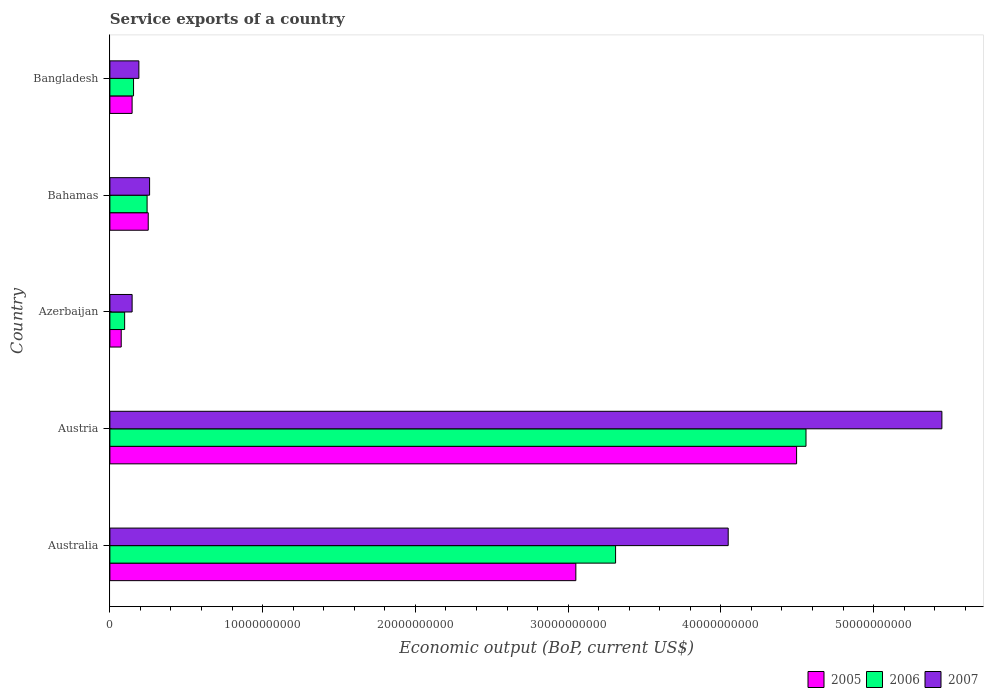How many different coloured bars are there?
Your answer should be compact. 3. Are the number of bars per tick equal to the number of legend labels?
Keep it short and to the point. Yes. Are the number of bars on each tick of the Y-axis equal?
Offer a very short reply. Yes. What is the label of the 5th group of bars from the top?
Keep it short and to the point. Australia. What is the service exports in 2007 in Azerbaijan?
Your response must be concise. 1.46e+09. Across all countries, what is the maximum service exports in 2006?
Provide a succinct answer. 4.56e+1. Across all countries, what is the minimum service exports in 2006?
Offer a very short reply. 9.65e+08. In which country was the service exports in 2007 minimum?
Keep it short and to the point. Azerbaijan. What is the total service exports in 2007 in the graph?
Your answer should be very brief. 1.01e+11. What is the difference between the service exports in 2007 in Azerbaijan and that in Bangladesh?
Make the answer very short. -4.42e+08. What is the difference between the service exports in 2006 in Bangladesh and the service exports in 2007 in Azerbaijan?
Offer a very short reply. 9.36e+07. What is the average service exports in 2007 per country?
Make the answer very short. 2.02e+1. What is the difference between the service exports in 2005 and service exports in 2006 in Bahamas?
Offer a terse response. 7.48e+07. In how many countries, is the service exports in 2005 greater than 54000000000 US$?
Keep it short and to the point. 0. What is the ratio of the service exports in 2007 in Azerbaijan to that in Bahamas?
Make the answer very short. 0.56. Is the difference between the service exports in 2005 in Austria and Azerbaijan greater than the difference between the service exports in 2006 in Austria and Azerbaijan?
Provide a short and direct response. No. What is the difference between the highest and the second highest service exports in 2007?
Provide a short and direct response. 1.40e+1. What is the difference between the highest and the lowest service exports in 2007?
Give a very brief answer. 5.30e+1. In how many countries, is the service exports in 2006 greater than the average service exports in 2006 taken over all countries?
Your answer should be very brief. 2. What does the 2nd bar from the top in Bangladesh represents?
Provide a short and direct response. 2006. How many bars are there?
Your answer should be very brief. 15. How many countries are there in the graph?
Provide a succinct answer. 5. Does the graph contain any zero values?
Provide a short and direct response. No. Where does the legend appear in the graph?
Provide a short and direct response. Bottom right. How many legend labels are there?
Your answer should be very brief. 3. What is the title of the graph?
Give a very brief answer. Service exports of a country. Does "2014" appear as one of the legend labels in the graph?
Make the answer very short. No. What is the label or title of the X-axis?
Your response must be concise. Economic output (BoP, current US$). What is the label or title of the Y-axis?
Your answer should be very brief. Country. What is the Economic output (BoP, current US$) in 2005 in Australia?
Offer a very short reply. 3.05e+1. What is the Economic output (BoP, current US$) in 2006 in Australia?
Offer a very short reply. 3.31e+1. What is the Economic output (BoP, current US$) in 2007 in Australia?
Your response must be concise. 4.05e+1. What is the Economic output (BoP, current US$) of 2005 in Austria?
Provide a succinct answer. 4.50e+1. What is the Economic output (BoP, current US$) in 2006 in Austria?
Your answer should be compact. 4.56e+1. What is the Economic output (BoP, current US$) in 2007 in Austria?
Your answer should be compact. 5.45e+1. What is the Economic output (BoP, current US$) in 2005 in Azerbaijan?
Your response must be concise. 7.41e+08. What is the Economic output (BoP, current US$) in 2006 in Azerbaijan?
Provide a short and direct response. 9.65e+08. What is the Economic output (BoP, current US$) in 2007 in Azerbaijan?
Your answer should be very brief. 1.46e+09. What is the Economic output (BoP, current US$) in 2005 in Bahamas?
Provide a short and direct response. 2.51e+09. What is the Economic output (BoP, current US$) in 2006 in Bahamas?
Keep it short and to the point. 2.44e+09. What is the Economic output (BoP, current US$) in 2007 in Bahamas?
Keep it short and to the point. 2.60e+09. What is the Economic output (BoP, current US$) in 2005 in Bangladesh?
Keep it short and to the point. 1.45e+09. What is the Economic output (BoP, current US$) in 2006 in Bangladesh?
Your response must be concise. 1.55e+09. What is the Economic output (BoP, current US$) of 2007 in Bangladesh?
Make the answer very short. 1.90e+09. Across all countries, what is the maximum Economic output (BoP, current US$) in 2005?
Ensure brevity in your answer.  4.50e+1. Across all countries, what is the maximum Economic output (BoP, current US$) in 2006?
Ensure brevity in your answer.  4.56e+1. Across all countries, what is the maximum Economic output (BoP, current US$) of 2007?
Provide a short and direct response. 5.45e+1. Across all countries, what is the minimum Economic output (BoP, current US$) of 2005?
Keep it short and to the point. 7.41e+08. Across all countries, what is the minimum Economic output (BoP, current US$) of 2006?
Make the answer very short. 9.65e+08. Across all countries, what is the minimum Economic output (BoP, current US$) of 2007?
Offer a terse response. 1.46e+09. What is the total Economic output (BoP, current US$) of 2005 in the graph?
Make the answer very short. 8.02e+1. What is the total Economic output (BoP, current US$) of 2006 in the graph?
Your response must be concise. 8.36e+1. What is the total Economic output (BoP, current US$) in 2007 in the graph?
Keep it short and to the point. 1.01e+11. What is the difference between the Economic output (BoP, current US$) of 2005 in Australia and that in Austria?
Give a very brief answer. -1.45e+1. What is the difference between the Economic output (BoP, current US$) in 2006 in Australia and that in Austria?
Your answer should be very brief. -1.25e+1. What is the difference between the Economic output (BoP, current US$) in 2007 in Australia and that in Austria?
Your answer should be compact. -1.40e+1. What is the difference between the Economic output (BoP, current US$) in 2005 in Australia and that in Azerbaijan?
Offer a terse response. 2.98e+1. What is the difference between the Economic output (BoP, current US$) of 2006 in Australia and that in Azerbaijan?
Your response must be concise. 3.21e+1. What is the difference between the Economic output (BoP, current US$) in 2007 in Australia and that in Azerbaijan?
Offer a terse response. 3.90e+1. What is the difference between the Economic output (BoP, current US$) in 2005 in Australia and that in Bahamas?
Make the answer very short. 2.80e+1. What is the difference between the Economic output (BoP, current US$) in 2006 in Australia and that in Bahamas?
Your answer should be very brief. 3.07e+1. What is the difference between the Economic output (BoP, current US$) of 2007 in Australia and that in Bahamas?
Provide a succinct answer. 3.79e+1. What is the difference between the Economic output (BoP, current US$) of 2005 in Australia and that in Bangladesh?
Provide a short and direct response. 2.91e+1. What is the difference between the Economic output (BoP, current US$) in 2006 in Australia and that in Bangladesh?
Offer a very short reply. 3.16e+1. What is the difference between the Economic output (BoP, current US$) of 2007 in Australia and that in Bangladesh?
Make the answer very short. 3.86e+1. What is the difference between the Economic output (BoP, current US$) in 2005 in Austria and that in Azerbaijan?
Offer a terse response. 4.42e+1. What is the difference between the Economic output (BoP, current US$) in 2006 in Austria and that in Azerbaijan?
Provide a succinct answer. 4.46e+1. What is the difference between the Economic output (BoP, current US$) in 2007 in Austria and that in Azerbaijan?
Provide a succinct answer. 5.30e+1. What is the difference between the Economic output (BoP, current US$) in 2005 in Austria and that in Bahamas?
Make the answer very short. 4.24e+1. What is the difference between the Economic output (BoP, current US$) of 2006 in Austria and that in Bahamas?
Offer a terse response. 4.31e+1. What is the difference between the Economic output (BoP, current US$) in 2007 in Austria and that in Bahamas?
Your answer should be very brief. 5.19e+1. What is the difference between the Economic output (BoP, current US$) of 2005 in Austria and that in Bangladesh?
Make the answer very short. 4.35e+1. What is the difference between the Economic output (BoP, current US$) in 2006 in Austria and that in Bangladesh?
Offer a very short reply. 4.40e+1. What is the difference between the Economic output (BoP, current US$) in 2007 in Austria and that in Bangladesh?
Keep it short and to the point. 5.26e+1. What is the difference between the Economic output (BoP, current US$) in 2005 in Azerbaijan and that in Bahamas?
Keep it short and to the point. -1.77e+09. What is the difference between the Economic output (BoP, current US$) of 2006 in Azerbaijan and that in Bahamas?
Ensure brevity in your answer.  -1.47e+09. What is the difference between the Economic output (BoP, current US$) of 2007 in Azerbaijan and that in Bahamas?
Your answer should be compact. -1.14e+09. What is the difference between the Economic output (BoP, current US$) of 2005 in Azerbaijan and that in Bangladesh?
Provide a short and direct response. -7.13e+08. What is the difference between the Economic output (BoP, current US$) in 2006 in Azerbaijan and that in Bangladesh?
Your answer should be compact. -5.84e+08. What is the difference between the Economic output (BoP, current US$) of 2007 in Azerbaijan and that in Bangladesh?
Your response must be concise. -4.42e+08. What is the difference between the Economic output (BoP, current US$) of 2005 in Bahamas and that in Bangladesh?
Provide a short and direct response. 1.06e+09. What is the difference between the Economic output (BoP, current US$) of 2006 in Bahamas and that in Bangladesh?
Offer a very short reply. 8.87e+08. What is the difference between the Economic output (BoP, current US$) of 2007 in Bahamas and that in Bangladesh?
Your answer should be very brief. 7.02e+08. What is the difference between the Economic output (BoP, current US$) in 2005 in Australia and the Economic output (BoP, current US$) in 2006 in Austria?
Offer a very short reply. -1.51e+1. What is the difference between the Economic output (BoP, current US$) of 2005 in Australia and the Economic output (BoP, current US$) of 2007 in Austria?
Your answer should be compact. -2.40e+1. What is the difference between the Economic output (BoP, current US$) in 2006 in Australia and the Economic output (BoP, current US$) in 2007 in Austria?
Keep it short and to the point. -2.14e+1. What is the difference between the Economic output (BoP, current US$) of 2005 in Australia and the Economic output (BoP, current US$) of 2006 in Azerbaijan?
Offer a terse response. 2.95e+1. What is the difference between the Economic output (BoP, current US$) in 2005 in Australia and the Economic output (BoP, current US$) in 2007 in Azerbaijan?
Provide a short and direct response. 2.91e+1. What is the difference between the Economic output (BoP, current US$) of 2006 in Australia and the Economic output (BoP, current US$) of 2007 in Azerbaijan?
Offer a terse response. 3.17e+1. What is the difference between the Economic output (BoP, current US$) of 2005 in Australia and the Economic output (BoP, current US$) of 2006 in Bahamas?
Keep it short and to the point. 2.81e+1. What is the difference between the Economic output (BoP, current US$) in 2005 in Australia and the Economic output (BoP, current US$) in 2007 in Bahamas?
Your answer should be very brief. 2.79e+1. What is the difference between the Economic output (BoP, current US$) in 2006 in Australia and the Economic output (BoP, current US$) in 2007 in Bahamas?
Provide a succinct answer. 3.05e+1. What is the difference between the Economic output (BoP, current US$) of 2005 in Australia and the Economic output (BoP, current US$) of 2006 in Bangladesh?
Give a very brief answer. 2.90e+1. What is the difference between the Economic output (BoP, current US$) of 2005 in Australia and the Economic output (BoP, current US$) of 2007 in Bangladesh?
Make the answer very short. 2.86e+1. What is the difference between the Economic output (BoP, current US$) in 2006 in Australia and the Economic output (BoP, current US$) in 2007 in Bangladesh?
Your response must be concise. 3.12e+1. What is the difference between the Economic output (BoP, current US$) in 2005 in Austria and the Economic output (BoP, current US$) in 2006 in Azerbaijan?
Offer a terse response. 4.40e+1. What is the difference between the Economic output (BoP, current US$) of 2005 in Austria and the Economic output (BoP, current US$) of 2007 in Azerbaijan?
Give a very brief answer. 4.35e+1. What is the difference between the Economic output (BoP, current US$) in 2006 in Austria and the Economic output (BoP, current US$) in 2007 in Azerbaijan?
Your answer should be compact. 4.41e+1. What is the difference between the Economic output (BoP, current US$) of 2005 in Austria and the Economic output (BoP, current US$) of 2006 in Bahamas?
Give a very brief answer. 4.25e+1. What is the difference between the Economic output (BoP, current US$) of 2005 in Austria and the Economic output (BoP, current US$) of 2007 in Bahamas?
Your answer should be very brief. 4.24e+1. What is the difference between the Economic output (BoP, current US$) of 2006 in Austria and the Economic output (BoP, current US$) of 2007 in Bahamas?
Make the answer very short. 4.30e+1. What is the difference between the Economic output (BoP, current US$) of 2005 in Austria and the Economic output (BoP, current US$) of 2006 in Bangladesh?
Offer a very short reply. 4.34e+1. What is the difference between the Economic output (BoP, current US$) in 2005 in Austria and the Economic output (BoP, current US$) in 2007 in Bangladesh?
Your answer should be very brief. 4.31e+1. What is the difference between the Economic output (BoP, current US$) of 2006 in Austria and the Economic output (BoP, current US$) of 2007 in Bangladesh?
Ensure brevity in your answer.  4.37e+1. What is the difference between the Economic output (BoP, current US$) of 2005 in Azerbaijan and the Economic output (BoP, current US$) of 2006 in Bahamas?
Your answer should be very brief. -1.69e+09. What is the difference between the Economic output (BoP, current US$) of 2005 in Azerbaijan and the Economic output (BoP, current US$) of 2007 in Bahamas?
Give a very brief answer. -1.86e+09. What is the difference between the Economic output (BoP, current US$) of 2006 in Azerbaijan and the Economic output (BoP, current US$) of 2007 in Bahamas?
Your answer should be compact. -1.63e+09. What is the difference between the Economic output (BoP, current US$) of 2005 in Azerbaijan and the Economic output (BoP, current US$) of 2006 in Bangladesh?
Offer a very short reply. -8.08e+08. What is the difference between the Economic output (BoP, current US$) of 2005 in Azerbaijan and the Economic output (BoP, current US$) of 2007 in Bangladesh?
Provide a succinct answer. -1.16e+09. What is the difference between the Economic output (BoP, current US$) in 2006 in Azerbaijan and the Economic output (BoP, current US$) in 2007 in Bangladesh?
Give a very brief answer. -9.32e+08. What is the difference between the Economic output (BoP, current US$) of 2005 in Bahamas and the Economic output (BoP, current US$) of 2006 in Bangladesh?
Your response must be concise. 9.62e+08. What is the difference between the Economic output (BoP, current US$) in 2005 in Bahamas and the Economic output (BoP, current US$) in 2007 in Bangladesh?
Ensure brevity in your answer.  6.14e+08. What is the difference between the Economic output (BoP, current US$) in 2006 in Bahamas and the Economic output (BoP, current US$) in 2007 in Bangladesh?
Keep it short and to the point. 5.39e+08. What is the average Economic output (BoP, current US$) in 2005 per country?
Provide a succinct answer. 1.60e+1. What is the average Economic output (BoP, current US$) in 2006 per country?
Your response must be concise. 1.67e+1. What is the average Economic output (BoP, current US$) of 2007 per country?
Give a very brief answer. 2.02e+1. What is the difference between the Economic output (BoP, current US$) of 2005 and Economic output (BoP, current US$) of 2006 in Australia?
Your response must be concise. -2.60e+09. What is the difference between the Economic output (BoP, current US$) of 2005 and Economic output (BoP, current US$) of 2007 in Australia?
Ensure brevity in your answer.  -9.97e+09. What is the difference between the Economic output (BoP, current US$) in 2006 and Economic output (BoP, current US$) in 2007 in Australia?
Provide a short and direct response. -7.37e+09. What is the difference between the Economic output (BoP, current US$) in 2005 and Economic output (BoP, current US$) in 2006 in Austria?
Provide a short and direct response. -6.15e+08. What is the difference between the Economic output (BoP, current US$) of 2005 and Economic output (BoP, current US$) of 2007 in Austria?
Offer a very short reply. -9.51e+09. What is the difference between the Economic output (BoP, current US$) in 2006 and Economic output (BoP, current US$) in 2007 in Austria?
Your response must be concise. -8.90e+09. What is the difference between the Economic output (BoP, current US$) in 2005 and Economic output (BoP, current US$) in 2006 in Azerbaijan?
Your answer should be compact. -2.24e+08. What is the difference between the Economic output (BoP, current US$) of 2005 and Economic output (BoP, current US$) of 2007 in Azerbaijan?
Offer a very short reply. -7.14e+08. What is the difference between the Economic output (BoP, current US$) in 2006 and Economic output (BoP, current US$) in 2007 in Azerbaijan?
Ensure brevity in your answer.  -4.90e+08. What is the difference between the Economic output (BoP, current US$) in 2005 and Economic output (BoP, current US$) in 2006 in Bahamas?
Keep it short and to the point. 7.48e+07. What is the difference between the Economic output (BoP, current US$) of 2005 and Economic output (BoP, current US$) of 2007 in Bahamas?
Give a very brief answer. -8.84e+07. What is the difference between the Economic output (BoP, current US$) of 2006 and Economic output (BoP, current US$) of 2007 in Bahamas?
Your answer should be compact. -1.63e+08. What is the difference between the Economic output (BoP, current US$) in 2005 and Economic output (BoP, current US$) in 2006 in Bangladesh?
Your answer should be very brief. -9.44e+07. What is the difference between the Economic output (BoP, current US$) in 2005 and Economic output (BoP, current US$) in 2007 in Bangladesh?
Provide a succinct answer. -4.43e+08. What is the difference between the Economic output (BoP, current US$) in 2006 and Economic output (BoP, current US$) in 2007 in Bangladesh?
Offer a very short reply. -3.48e+08. What is the ratio of the Economic output (BoP, current US$) in 2005 in Australia to that in Austria?
Your answer should be compact. 0.68. What is the ratio of the Economic output (BoP, current US$) in 2006 in Australia to that in Austria?
Provide a succinct answer. 0.73. What is the ratio of the Economic output (BoP, current US$) of 2007 in Australia to that in Austria?
Ensure brevity in your answer.  0.74. What is the ratio of the Economic output (BoP, current US$) of 2005 in Australia to that in Azerbaijan?
Ensure brevity in your answer.  41.14. What is the ratio of the Economic output (BoP, current US$) of 2006 in Australia to that in Azerbaijan?
Give a very brief answer. 34.3. What is the ratio of the Economic output (BoP, current US$) of 2007 in Australia to that in Azerbaijan?
Your response must be concise. 27.81. What is the ratio of the Economic output (BoP, current US$) of 2005 in Australia to that in Bahamas?
Offer a very short reply. 12.15. What is the ratio of the Economic output (BoP, current US$) in 2006 in Australia to that in Bahamas?
Provide a succinct answer. 13.59. What is the ratio of the Economic output (BoP, current US$) in 2007 in Australia to that in Bahamas?
Your response must be concise. 15.57. What is the ratio of the Economic output (BoP, current US$) of 2005 in Australia to that in Bangladesh?
Keep it short and to the point. 20.97. What is the ratio of the Economic output (BoP, current US$) in 2006 in Australia to that in Bangladesh?
Offer a terse response. 21.37. What is the ratio of the Economic output (BoP, current US$) in 2007 in Australia to that in Bangladesh?
Your response must be concise. 21.34. What is the ratio of the Economic output (BoP, current US$) of 2005 in Austria to that in Azerbaijan?
Keep it short and to the point. 60.64. What is the ratio of the Economic output (BoP, current US$) of 2006 in Austria to that in Azerbaijan?
Offer a terse response. 47.21. What is the ratio of the Economic output (BoP, current US$) of 2007 in Austria to that in Azerbaijan?
Offer a terse response. 37.43. What is the ratio of the Economic output (BoP, current US$) in 2005 in Austria to that in Bahamas?
Your response must be concise. 17.91. What is the ratio of the Economic output (BoP, current US$) of 2006 in Austria to that in Bahamas?
Give a very brief answer. 18.71. What is the ratio of the Economic output (BoP, current US$) of 2007 in Austria to that in Bahamas?
Offer a terse response. 20.96. What is the ratio of the Economic output (BoP, current US$) in 2005 in Austria to that in Bangladesh?
Offer a very short reply. 30.91. What is the ratio of the Economic output (BoP, current US$) in 2006 in Austria to that in Bangladesh?
Your answer should be very brief. 29.42. What is the ratio of the Economic output (BoP, current US$) of 2007 in Austria to that in Bangladesh?
Offer a very short reply. 28.71. What is the ratio of the Economic output (BoP, current US$) of 2005 in Azerbaijan to that in Bahamas?
Your answer should be very brief. 0.3. What is the ratio of the Economic output (BoP, current US$) in 2006 in Azerbaijan to that in Bahamas?
Ensure brevity in your answer.  0.4. What is the ratio of the Economic output (BoP, current US$) of 2007 in Azerbaijan to that in Bahamas?
Your response must be concise. 0.56. What is the ratio of the Economic output (BoP, current US$) of 2005 in Azerbaijan to that in Bangladesh?
Your response must be concise. 0.51. What is the ratio of the Economic output (BoP, current US$) of 2006 in Azerbaijan to that in Bangladesh?
Your response must be concise. 0.62. What is the ratio of the Economic output (BoP, current US$) of 2007 in Azerbaijan to that in Bangladesh?
Offer a terse response. 0.77. What is the ratio of the Economic output (BoP, current US$) in 2005 in Bahamas to that in Bangladesh?
Your answer should be compact. 1.73. What is the ratio of the Economic output (BoP, current US$) of 2006 in Bahamas to that in Bangladesh?
Keep it short and to the point. 1.57. What is the ratio of the Economic output (BoP, current US$) of 2007 in Bahamas to that in Bangladesh?
Ensure brevity in your answer.  1.37. What is the difference between the highest and the second highest Economic output (BoP, current US$) of 2005?
Provide a short and direct response. 1.45e+1. What is the difference between the highest and the second highest Economic output (BoP, current US$) of 2006?
Offer a terse response. 1.25e+1. What is the difference between the highest and the second highest Economic output (BoP, current US$) in 2007?
Give a very brief answer. 1.40e+1. What is the difference between the highest and the lowest Economic output (BoP, current US$) of 2005?
Make the answer very short. 4.42e+1. What is the difference between the highest and the lowest Economic output (BoP, current US$) in 2006?
Your answer should be compact. 4.46e+1. What is the difference between the highest and the lowest Economic output (BoP, current US$) in 2007?
Provide a succinct answer. 5.30e+1. 